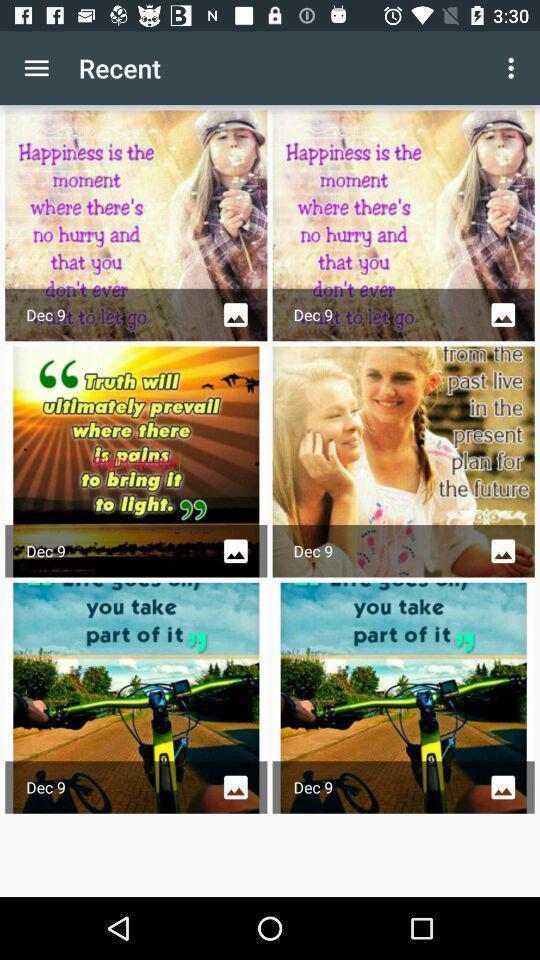Describe the key features of this screenshot. Pdf files showing in this page. 